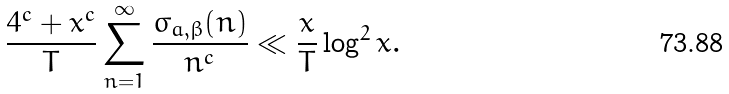Convert formula to latex. <formula><loc_0><loc_0><loc_500><loc_500>\frac { 4 ^ { c } + x ^ { c } } { T } \sum _ { n = 1 } ^ { \infty } \frac { \sigma _ { a , \beta } ( n ) } { n ^ { c } } \ll \frac { x } { T } \log ^ { 2 } x .</formula> 